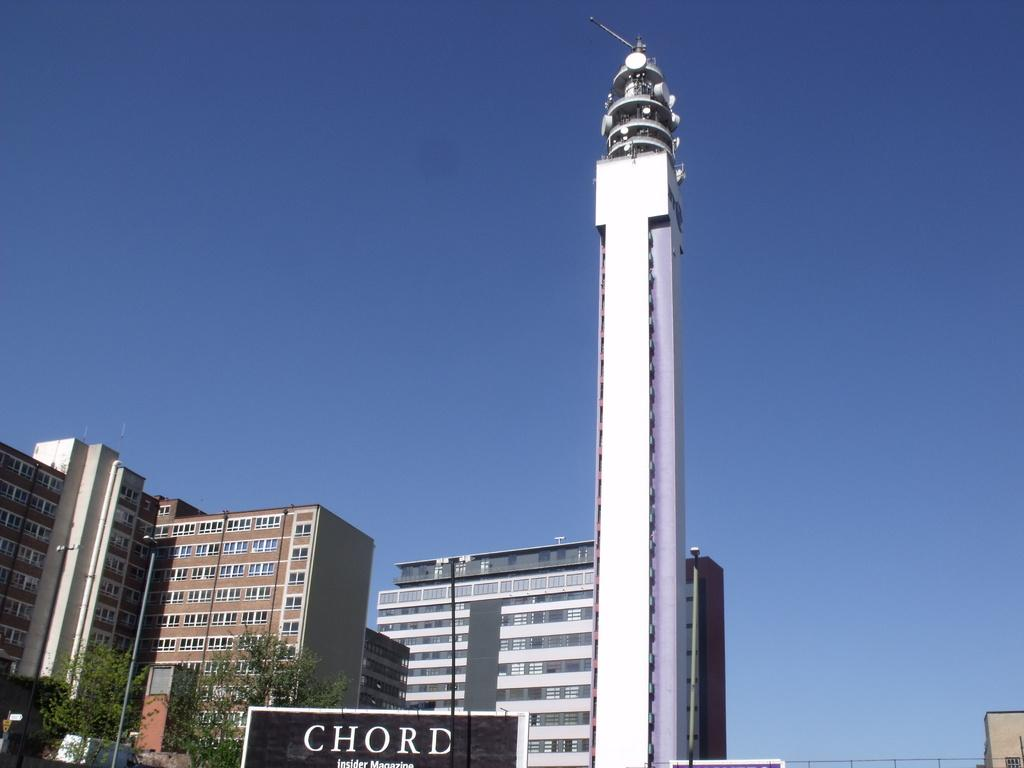What is the main structure in the image? There is a tower in the image. What other structures can be seen in the image? There are buildings in the image. What architectural features are present in the image? Walls and windows are visible in the image. What type of vegetation is at the bottom of the image? Trees are at the bottom of the image. What objects are at the bottom of the image? Poles and hoarding are at the bottom of the image. What is the condition of the sky in the background? The sky is clear in the background. Where is the crown placed in the image? There is no crown present in the image. What type of food is being served in the lunchroom in the image? There is no lunchroom present in the image. 